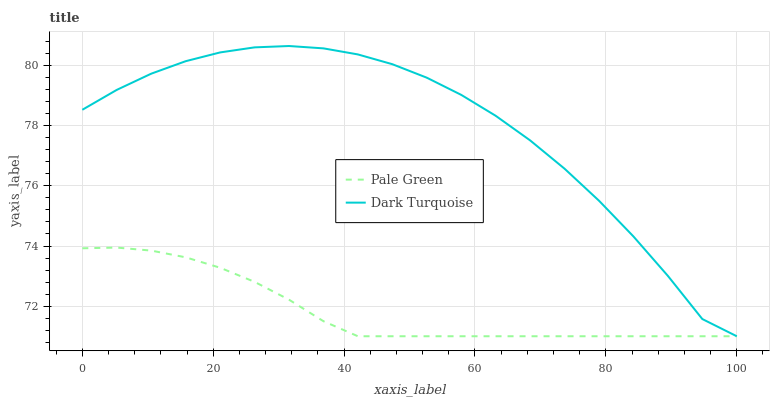Does Pale Green have the minimum area under the curve?
Answer yes or no. Yes. Does Dark Turquoise have the maximum area under the curve?
Answer yes or no. Yes. Does Pale Green have the maximum area under the curve?
Answer yes or no. No. Is Pale Green the smoothest?
Answer yes or no. Yes. Is Dark Turquoise the roughest?
Answer yes or no. Yes. Is Pale Green the roughest?
Answer yes or no. No. Does Dark Turquoise have the lowest value?
Answer yes or no. Yes. Does Dark Turquoise have the highest value?
Answer yes or no. Yes. Does Pale Green have the highest value?
Answer yes or no. No. Does Dark Turquoise intersect Pale Green?
Answer yes or no. Yes. Is Dark Turquoise less than Pale Green?
Answer yes or no. No. Is Dark Turquoise greater than Pale Green?
Answer yes or no. No. 